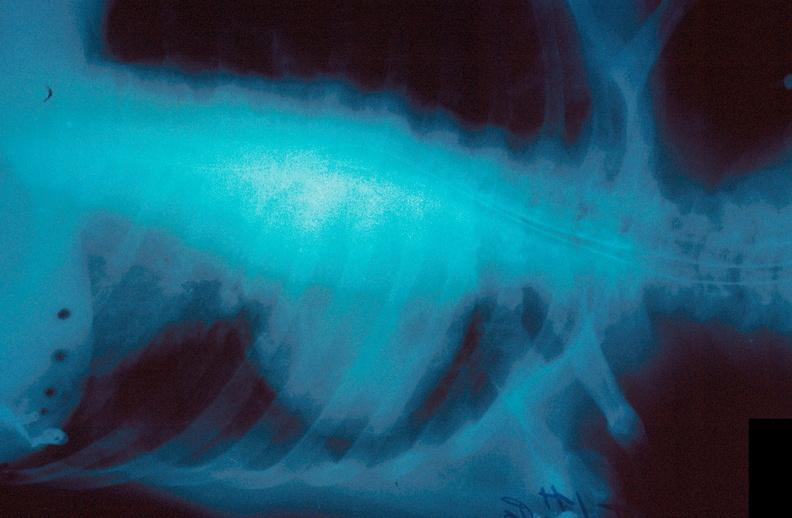does this image show lung, hematoma?
Answer the question using a single word or phrase. Yes 